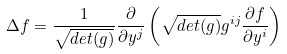Convert formula to latex. <formula><loc_0><loc_0><loc_500><loc_500>\Delta f = \frac { 1 } { \sqrt { d e t ( g ) } } \frac { \partial } { \partial y ^ { j } } \left ( \sqrt { d e t ( g ) } g ^ { i j } \frac { \partial f } { \partial y ^ { i } } \right )</formula> 